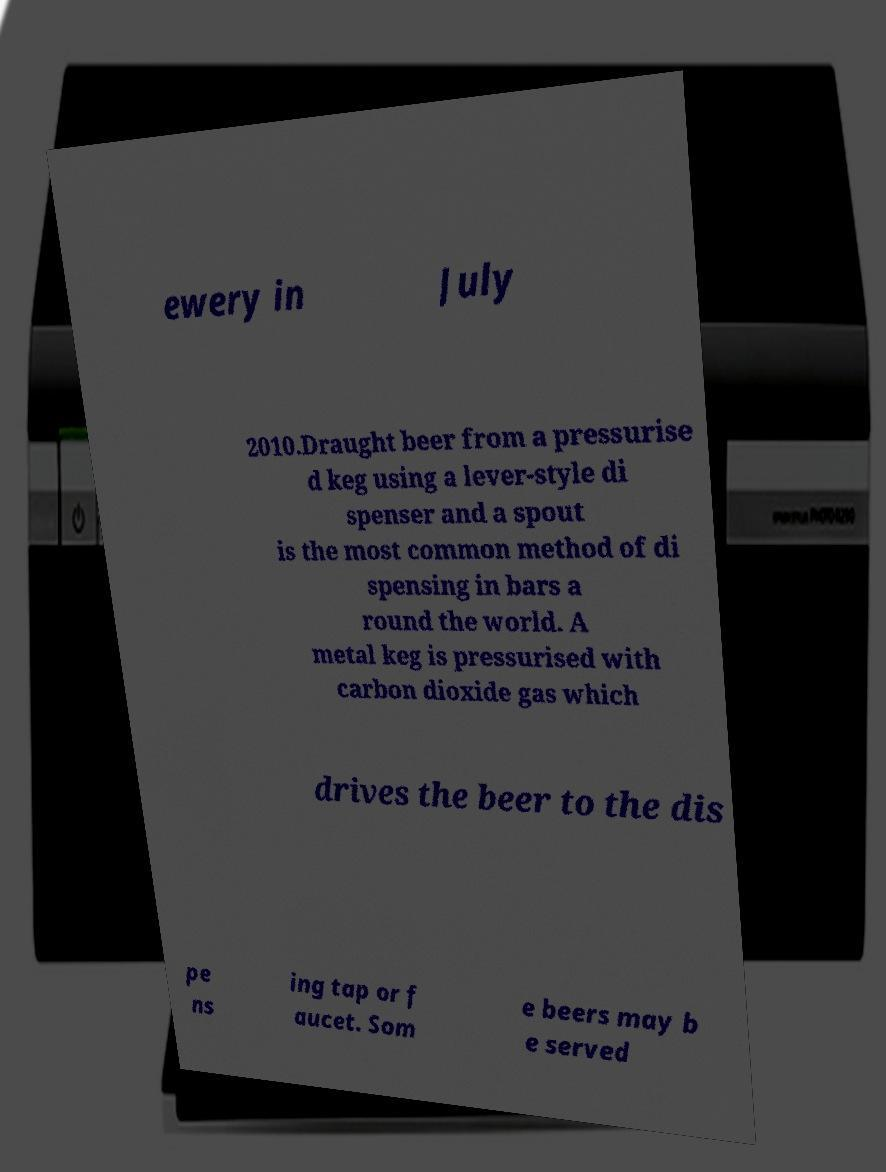What messages or text are displayed in this image? I need them in a readable, typed format. ewery in July 2010.Draught beer from a pressurise d keg using a lever-style di spenser and a spout is the most common method of di spensing in bars a round the world. A metal keg is pressurised with carbon dioxide gas which drives the beer to the dis pe ns ing tap or f aucet. Som e beers may b e served 